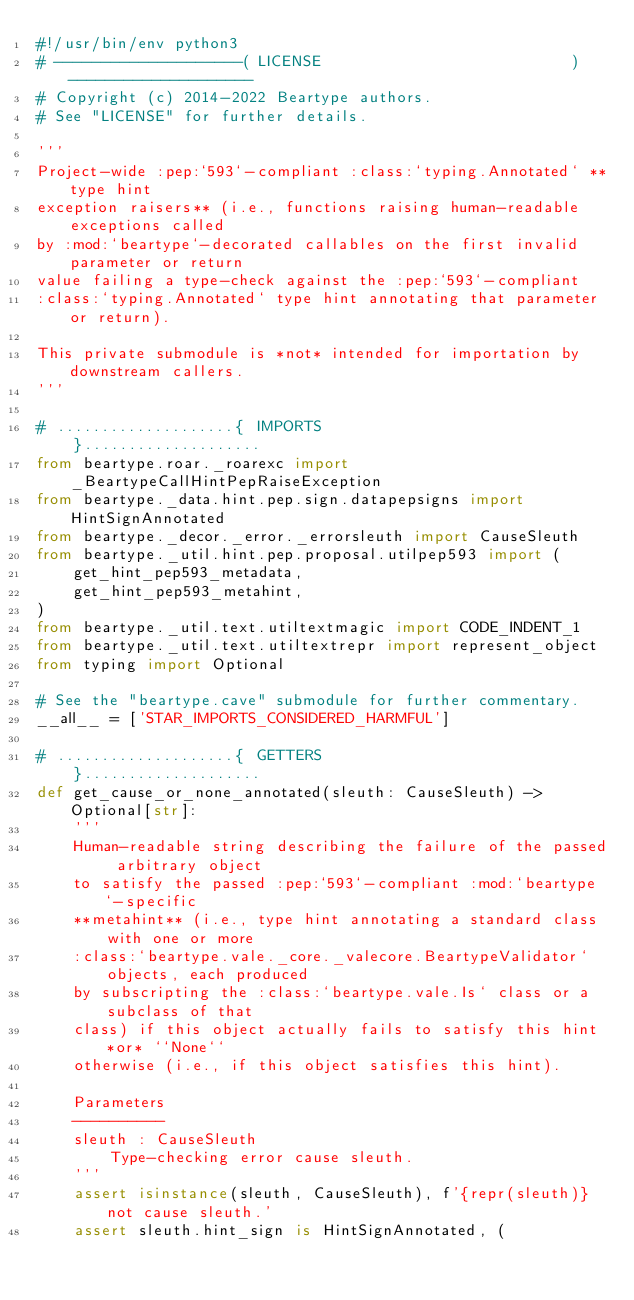Convert code to text. <code><loc_0><loc_0><loc_500><loc_500><_Python_>#!/usr/bin/env python3
# --------------------( LICENSE                           )--------------------
# Copyright (c) 2014-2022 Beartype authors.
# See "LICENSE" for further details.

'''
Project-wide :pep:`593`-compliant :class:`typing.Annotated` **type hint
exception raisers** (i.e., functions raising human-readable exceptions called
by :mod:`beartype`-decorated callables on the first invalid parameter or return
value failing a type-check against the :pep:`593`-compliant
:class:`typing.Annotated` type hint annotating that parameter or return).

This private submodule is *not* intended for importation by downstream callers.
'''

# ....................{ IMPORTS                           }....................
from beartype.roar._roarexc import _BeartypeCallHintPepRaiseException
from beartype._data.hint.pep.sign.datapepsigns import HintSignAnnotated
from beartype._decor._error._errorsleuth import CauseSleuth
from beartype._util.hint.pep.proposal.utilpep593 import (
    get_hint_pep593_metadata,
    get_hint_pep593_metahint,
)
from beartype._util.text.utiltextmagic import CODE_INDENT_1
from beartype._util.text.utiltextrepr import represent_object
from typing import Optional

# See the "beartype.cave" submodule for further commentary.
__all__ = ['STAR_IMPORTS_CONSIDERED_HARMFUL']

# ....................{ GETTERS                           }....................
def get_cause_or_none_annotated(sleuth: CauseSleuth) -> Optional[str]:
    '''
    Human-readable string describing the failure of the passed arbitrary object
    to satisfy the passed :pep:`593`-compliant :mod:`beartype`-specific
    **metahint** (i.e., type hint annotating a standard class with one or more
    :class:`beartype.vale._core._valecore.BeartypeValidator` objects, each produced
    by subscripting the :class:`beartype.vale.Is` class or a subclass of that
    class) if this object actually fails to satisfy this hint *or* ``None``
    otherwise (i.e., if this object satisfies this hint).

    Parameters
    ----------
    sleuth : CauseSleuth
        Type-checking error cause sleuth.
    '''
    assert isinstance(sleuth, CauseSleuth), f'{repr(sleuth)} not cause sleuth.'
    assert sleuth.hint_sign is HintSignAnnotated, (</code> 